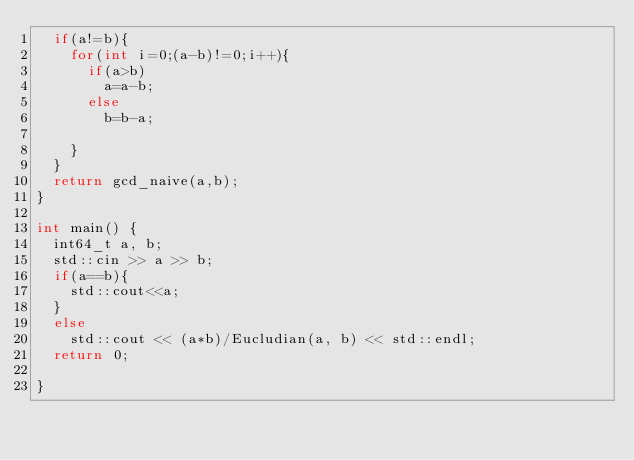Convert code to text. <code><loc_0><loc_0><loc_500><loc_500><_C++_>	if(a!=b){
		for(int i=0;(a-b)!=0;i++){
			if(a>b)
				a=a-b;
			else
				b=b-a;
			
		}
	}
	return gcd_naive(a,b);
}

int main() {
  int64_t a, b;
  std::cin >> a >> b;
  if(a==b){
	  std::cout<<a;
  }
  else
	  std::cout << (a*b)/Eucludian(a, b) << std::endl;
  return 0;
  
}
</code> 